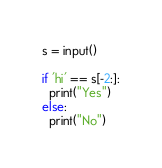Convert code to text. <code><loc_0><loc_0><loc_500><loc_500><_Python_>s = input()

if 'hi' == s[-2:]:
  print("Yes")
else:
  print("No")</code> 